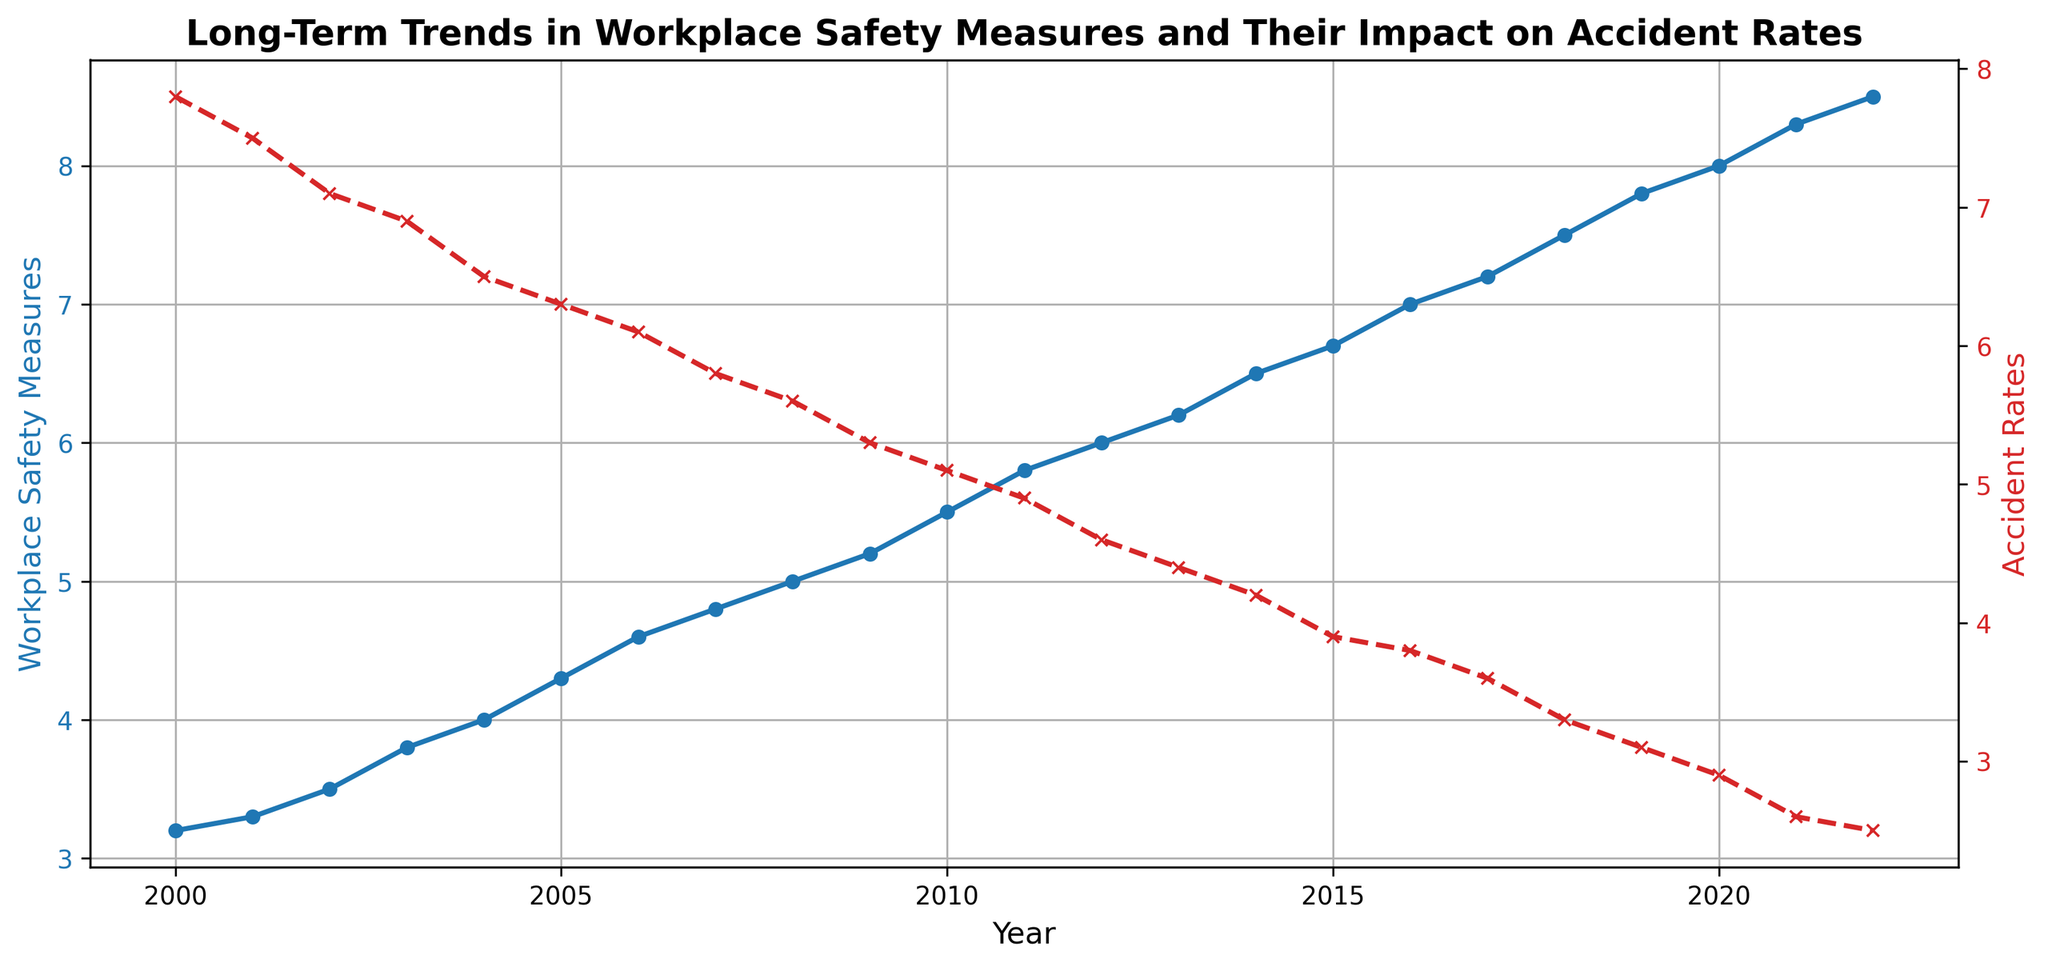What year did the Workplace Safety Measures first reach above 8.0? To find the first year where Workplace Safety Measures exceeded 8.0, we look at the blue line graph and identify the first data point above 8.0. The plot shows this happens in 2020.
Answer: 2020 What was the trend in Accident Rates from 2003 to 2006? To determine the trend, we observe the red dashed line graph from 2003 to 2006. Accident Rates steadily decreased from 6.9 in 2003 to 6.1 in 2006.
Answer: Decreasing By how much did Accident Rates decrease from 2000 to 2022? Find the Accident Rates in 2000 and in 2022 on the red dashed line graph. Subtract the rate in 2022 (2.5) from the rate in 2000 (7.8), which gives a decrease of 7.8 - 2.5 = 5.3.
Answer: 5.3 Between which consecutive years did Workplace Safety Measures increase the most? To identify the largest increase, observe the blue line graph and find the years where Workplace Safety Measures have the largest upward jump. The biggest increase is between 2020 (8.0) and 2021 (8.3) with an increase of 0.3.
Answer: 2020-2021 What was the average Accident Rate between 2018 and 2022? Calculate the Accident Rates from 2018 to 2022 (3.3, 3.1, 2.9, 2.6, 2.5) and find their average. Sum these rates (3.3+3.1+2.9+2.6+2.5) = 14.4. Divide by the number of years (5) to get the average: 14.4/5 = 2.88.
Answer: 2.88 Do Workplace Safety Measures and Accident Rates show an inverse relationship over time? Examine the trends of the blue line (Workplace Safety Measures) and red dashed line (Accident Rates). As Workplace Safety Measures increase, Accident Rates decrease, indicating an inverse relationship.
Answer: Yes Which year had the lowest Accident Rate, and what was that rate? Identify the point where the red dashed line graph is at its lowest. The lowest rate occurs in 2022 with an Accident Rate of 2.5.
Answer: 2022, 2.5 In which year do Workplace Safety Measures and Accident Rates meet where one line crosses the other? There isn't a year where the two lines cross each other directly on the graph.
Answer: None What is the difference in Workplace Safety Measures between 2000 and 2010? Find the Workplace Safety Measures for 2000 (3.2) and 2010 (5.5) on the blue line graph. Subtracting these gives 5.5 - 3.2 = 2.3.
Answer: 2.3 How much did Accident Rates decline on average per year between 2000 and 2022? Calculate the total decline from 2000 (7.8) to 2022 (2.5) which is 7.8 - 2.5 = 5.3. Divide this decline by the number of years (2022-2000 = 22 years) to get the average yearly decline: 5.3 / 22 ≈ 0.24.
Answer: 0.24 